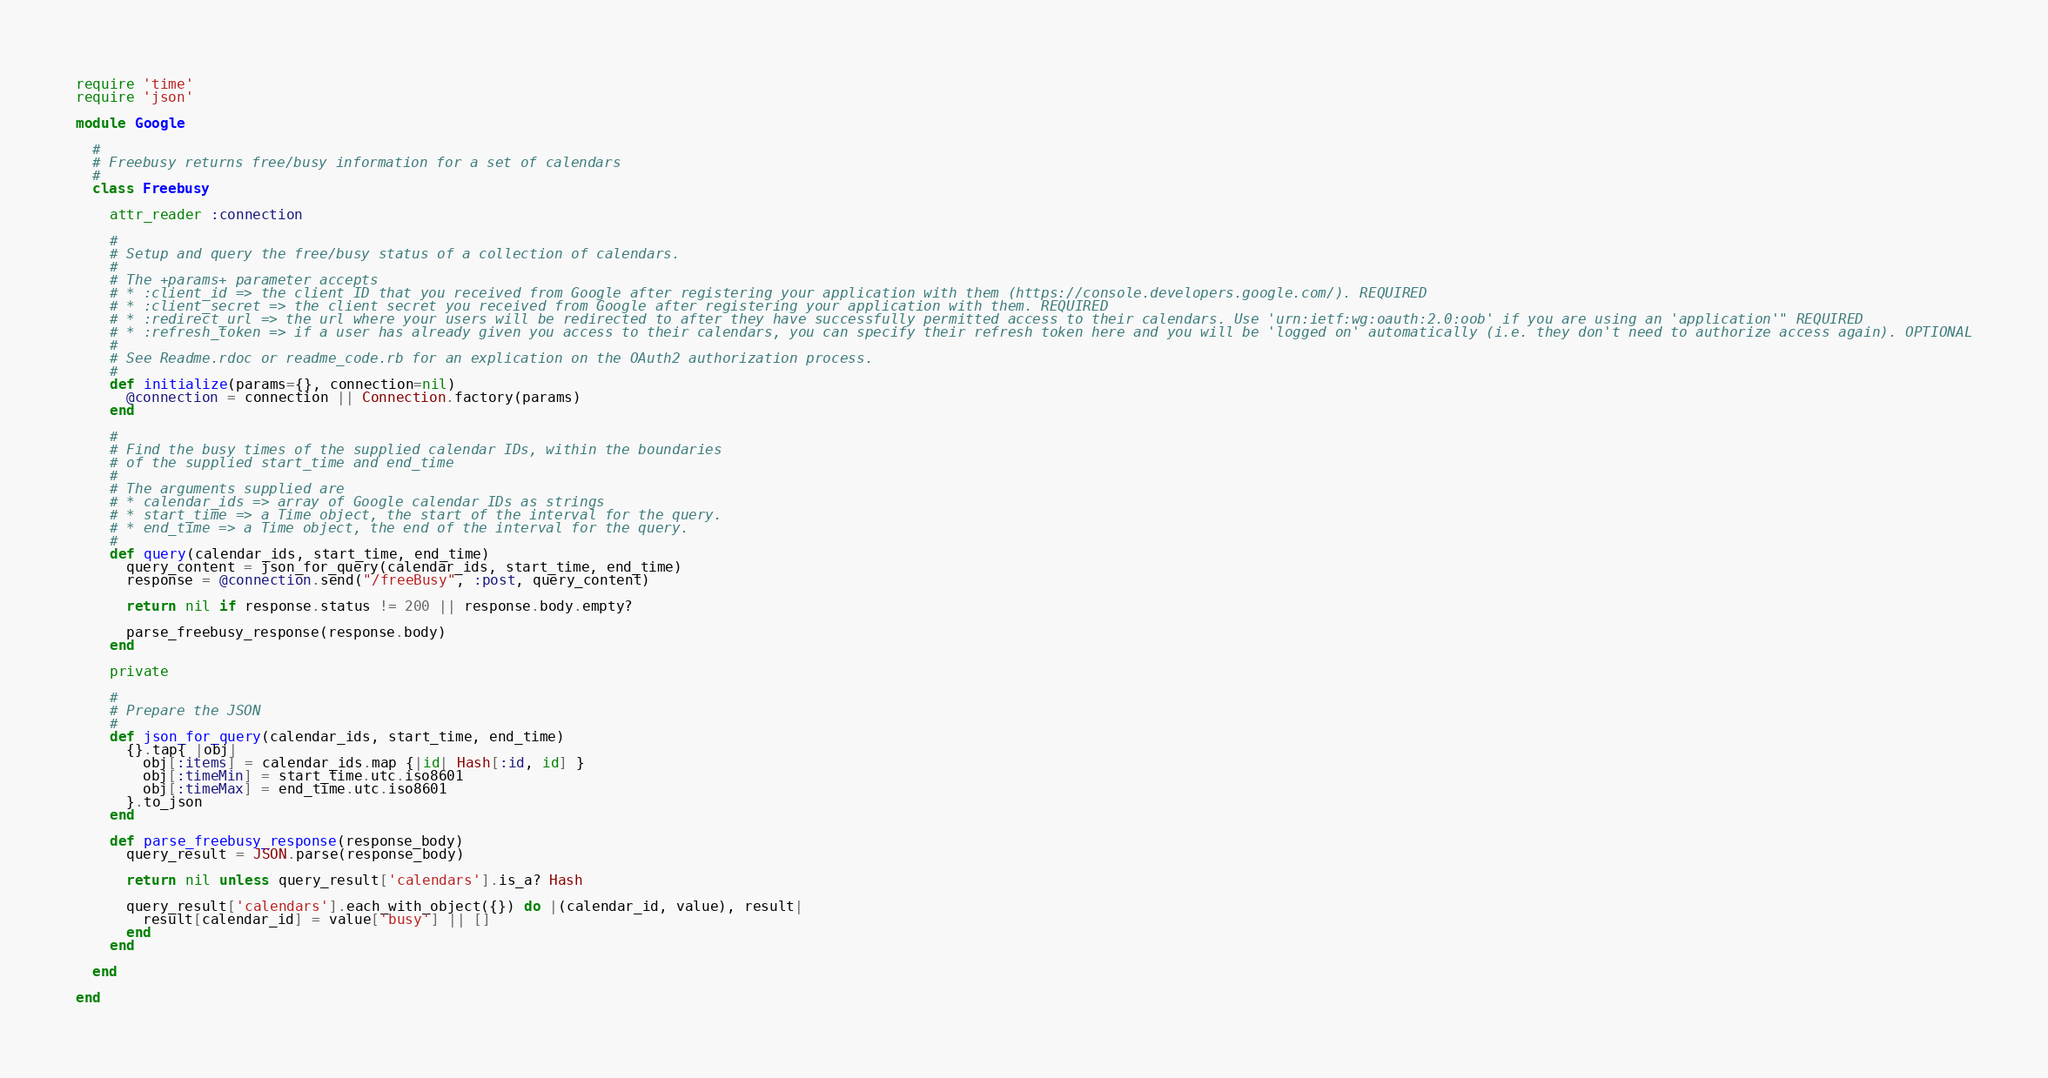Convert code to text. <code><loc_0><loc_0><loc_500><loc_500><_Ruby_>require 'time'
require 'json'

module Google

  #
  # Freebusy returns free/busy information for a set of calendars
  #
  class Freebusy

    attr_reader :connection

    #
    # Setup and query the free/busy status of a collection of calendars.
    #
    # The +params+ parameter accepts
    # * :client_id => the client ID that you received from Google after registering your application with them (https://console.developers.google.com/). REQUIRED
    # * :client_secret => the client secret you received from Google after registering your application with them. REQUIRED
    # * :redirect_url => the url where your users will be redirected to after they have successfully permitted access to their calendars. Use 'urn:ietf:wg:oauth:2.0:oob' if you are using an 'application'" REQUIRED
    # * :refresh_token => if a user has already given you access to their calendars, you can specify their refresh token here and you will be 'logged on' automatically (i.e. they don't need to authorize access again). OPTIONAL
    #
    # See Readme.rdoc or readme_code.rb for an explication on the OAuth2 authorization process.
    #
    def initialize(params={}, connection=nil)
      @connection = connection || Connection.factory(params)
    end

    #
    # Find the busy times of the supplied calendar IDs, within the boundaries
    # of the supplied start_time and end_time
    #
    # The arguments supplied are
    # * calendar_ids => array of Google calendar IDs as strings
    # * start_time => a Time object, the start of the interval for the query.
    # * end_time => a Time object, the end of the interval for the query.
    #
    def query(calendar_ids, start_time, end_time)
      query_content = json_for_query(calendar_ids, start_time, end_time)
      response = @connection.send("/freeBusy", :post, query_content)

      return nil if response.status != 200 || response.body.empty?

      parse_freebusy_response(response.body)
    end

    private

    #
    # Prepare the JSON 
    #
    def json_for_query(calendar_ids, start_time, end_time)
      {}.tap{ |obj|
        obj[:items] = calendar_ids.map {|id| Hash[:id, id] }
        obj[:timeMin] = start_time.utc.iso8601
        obj[:timeMax] = end_time.utc.iso8601
      }.to_json
    end

    def parse_freebusy_response(response_body)
      query_result = JSON.parse(response_body)

      return nil unless query_result['calendars'].is_a? Hash

      query_result['calendars'].each_with_object({}) do |(calendar_id, value), result|
        result[calendar_id] = value['busy'] || []
      end
    end

  end

end
</code> 